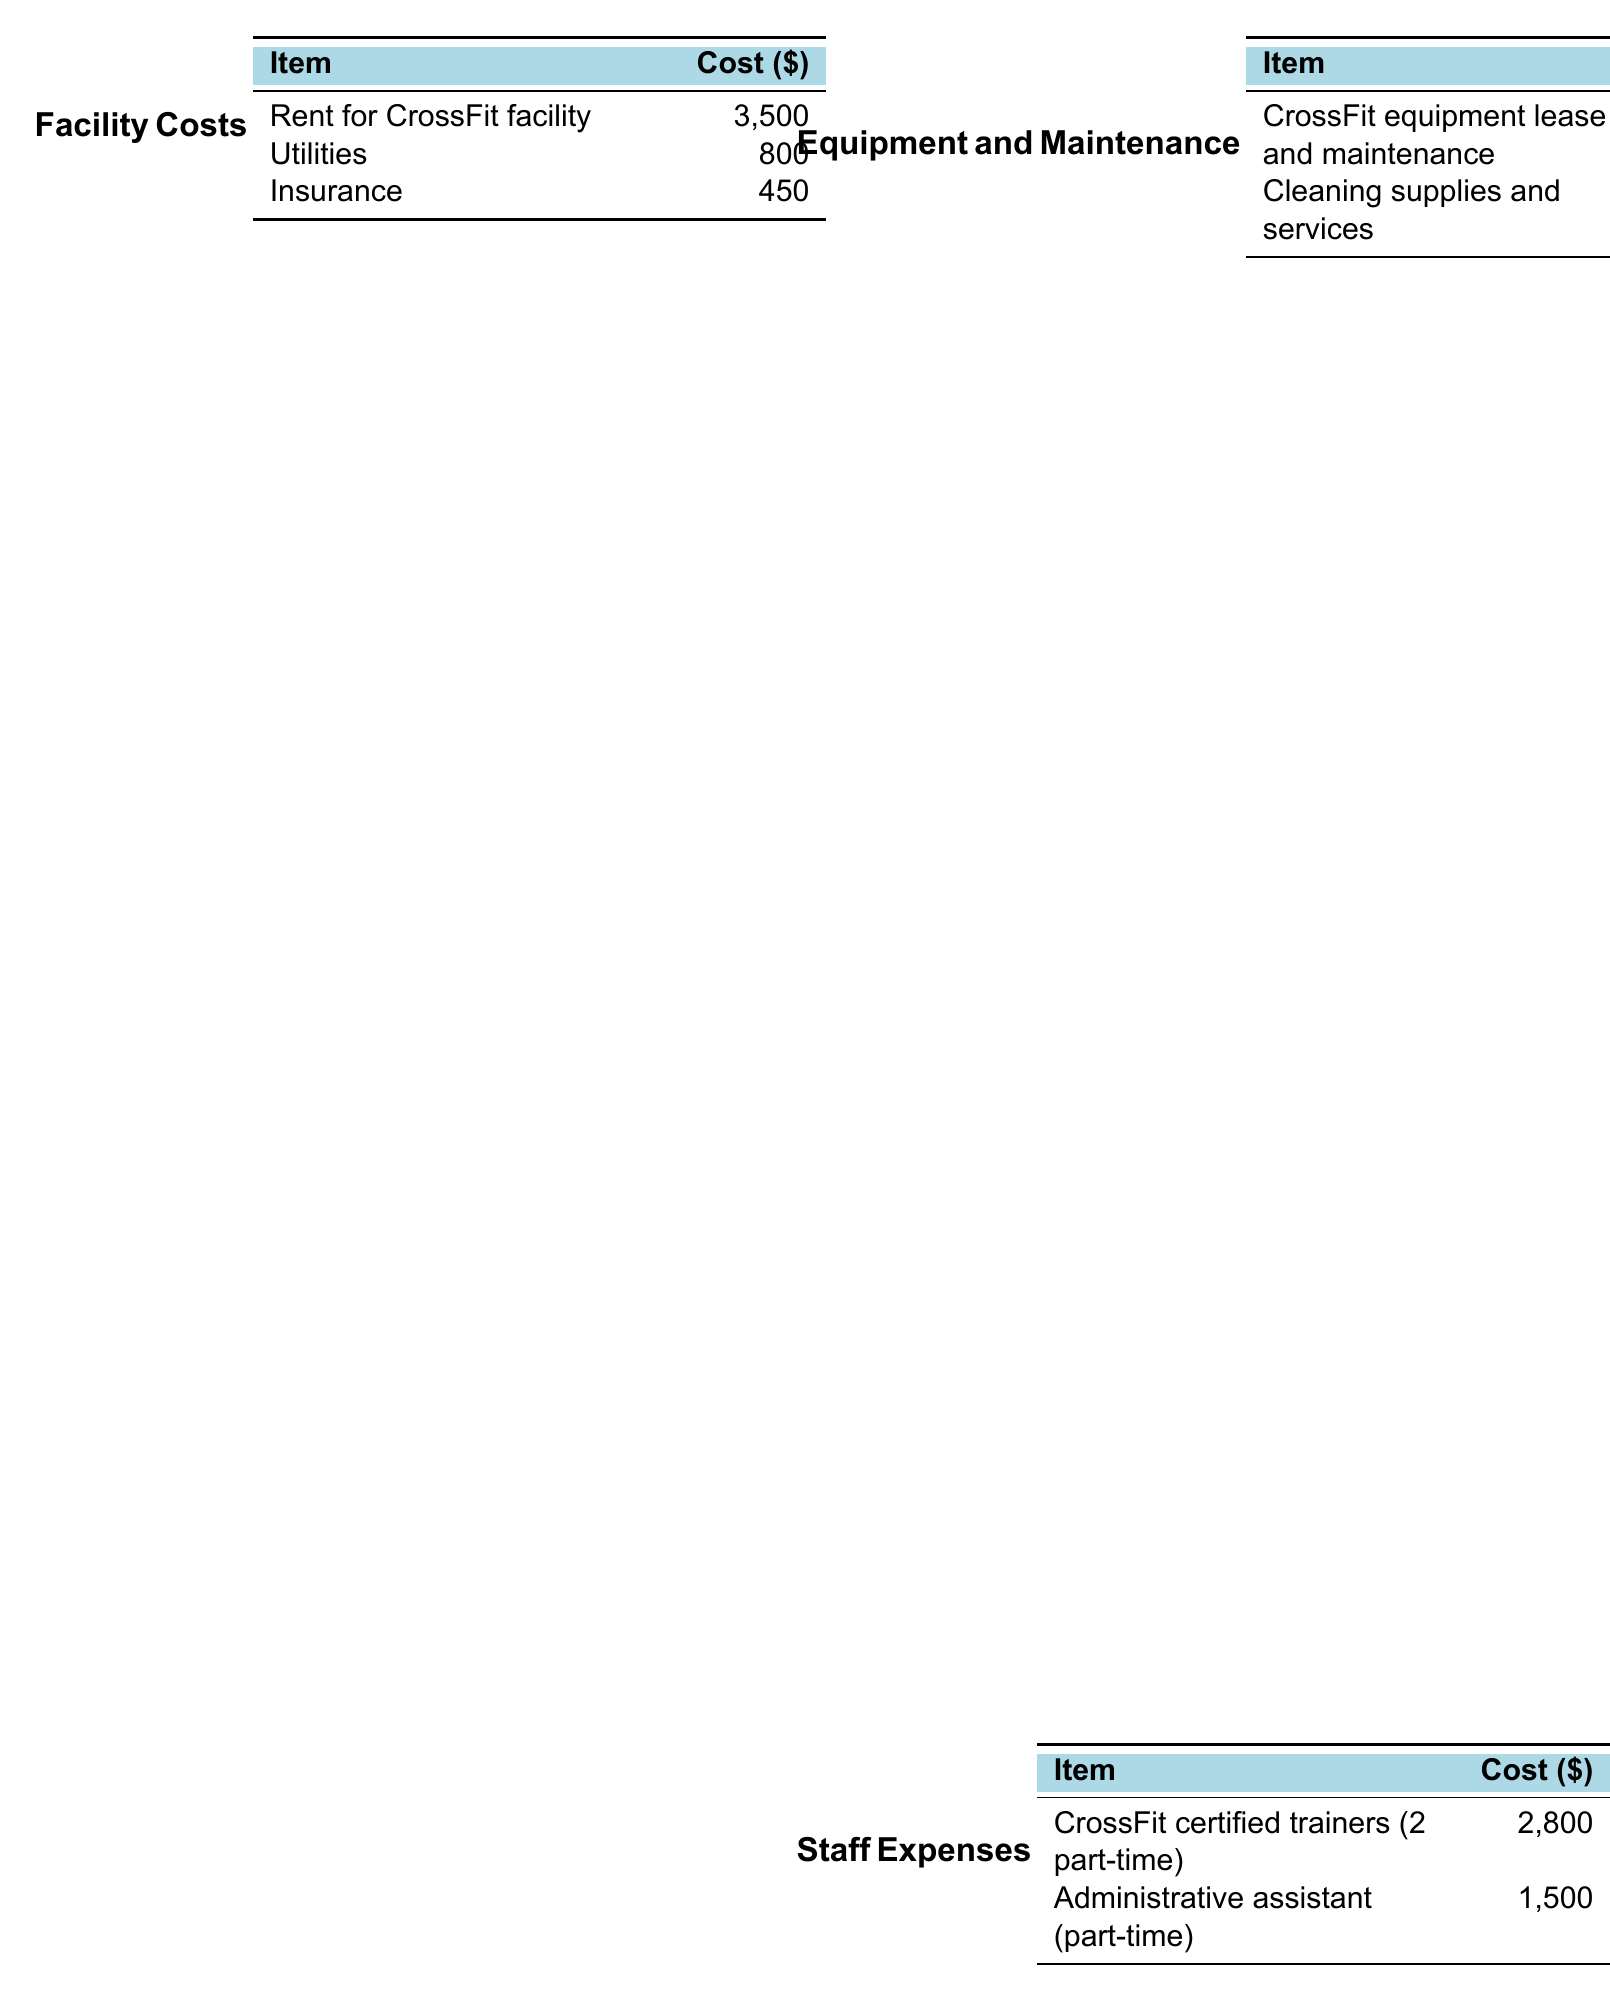what is the total monthly expense? The total monthly expenses are summarized at the end of the document, amounting to $11,575.
Answer: $11,575 how much is allocated for rent? The document specifies the rent for the CrossFit facility is listed under Facility Costs as $3,500.
Answer: $3,500 what is the cost for CrossFit equipment lease and maintenance? The cost for CrossFit equipment lease and maintenance is detailed in the Equipment and Maintenance section as $1,200.
Answer: $1,200 who is the part-time administrative assistant? The document mentions an administrative assistant as part of Staff Expenses without naming an individual.
Answer: Not specified how much is spent on veteran outreach programs? The document shows the cost for veteran outreach programs under Marketing and Outreach as $300.
Answer: $300 what are the total staff expenses? To calculate total staff expenses, add $2,800 and $1,500 from the Staff Expenses section, totaling $4,300.
Answer: $4,300 how much is budgeted for counseling materials and resources? The budget for counseling materials and resources is specifically noted as $200 in the Mental Health Services section.
Answer: $200 what are the miscellaneous expenses? The miscellaneous category includes office supplies and an emergency fund amounting to a total of $275.
Answer: $275 how much is spent on professional development? The spending on professional development is mentioned in the Mental Health Services section as $150.
Answer: $150 